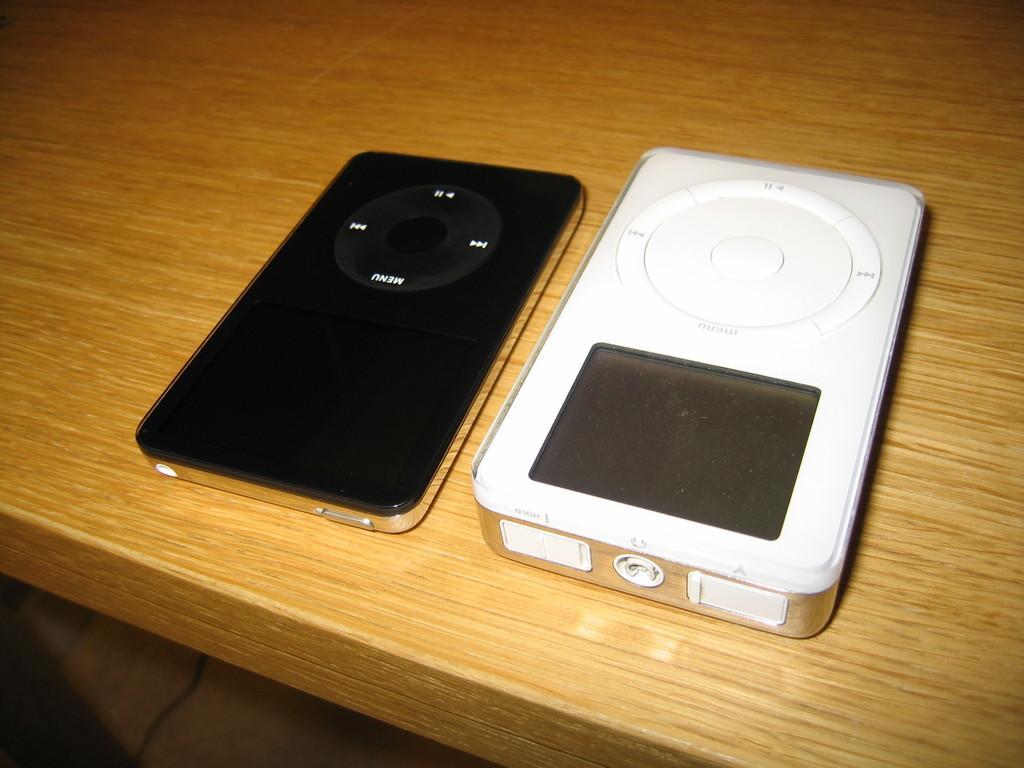Please provide a concise description of this image. In this image I can see there is an electronic device in white color on the table. Beside it there is another electronic device in black color. 